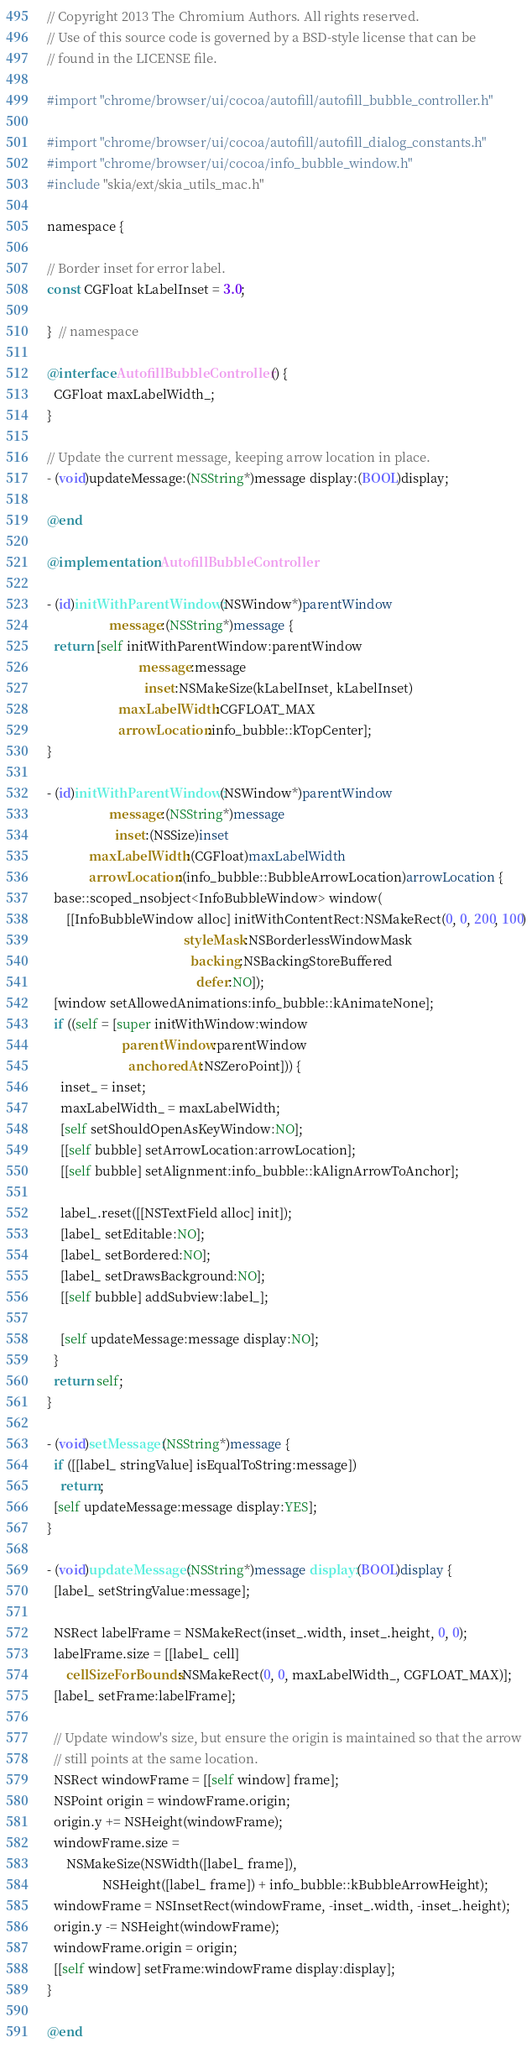<code> <loc_0><loc_0><loc_500><loc_500><_ObjectiveC_>// Copyright 2013 The Chromium Authors. All rights reserved.
// Use of this source code is governed by a BSD-style license that can be
// found in the LICENSE file.

#import "chrome/browser/ui/cocoa/autofill/autofill_bubble_controller.h"

#import "chrome/browser/ui/cocoa/autofill/autofill_dialog_constants.h"
#import "chrome/browser/ui/cocoa/info_bubble_window.h"
#include "skia/ext/skia_utils_mac.h"

namespace {

// Border inset for error label.
const CGFloat kLabelInset = 3.0;

}  // namespace

@interface AutofillBubbleController () {
  CGFloat maxLabelWidth_;
}

// Update the current message, keeping arrow location in place.
- (void)updateMessage:(NSString*)message display:(BOOL)display;

@end

@implementation AutofillBubbleController

- (id)initWithParentWindow:(NSWindow*)parentWindow
                   message:(NSString*)message {
  return [self initWithParentWindow:parentWindow
                            message:message
                              inset:NSMakeSize(kLabelInset, kLabelInset)
                      maxLabelWidth:CGFLOAT_MAX
                      arrowLocation:info_bubble::kTopCenter];
}

- (id)initWithParentWindow:(NSWindow*)parentWindow
                   message:(NSString*)message
                     inset:(NSSize)inset
             maxLabelWidth:(CGFloat)maxLabelWidth
             arrowLocation:(info_bubble::BubbleArrowLocation)arrowLocation {
  base::scoped_nsobject<InfoBubbleWindow> window(
      [[InfoBubbleWindow alloc] initWithContentRect:NSMakeRect(0, 0, 200, 100)
                                          styleMask:NSBorderlessWindowMask
                                            backing:NSBackingStoreBuffered
                                              defer:NO]);
  [window setAllowedAnimations:info_bubble::kAnimateNone];
  if ((self = [super initWithWindow:window
                       parentWindow:parentWindow
                         anchoredAt:NSZeroPoint])) {
    inset_ = inset;
    maxLabelWidth_ = maxLabelWidth;
    [self setShouldOpenAsKeyWindow:NO];
    [[self bubble] setArrowLocation:arrowLocation];
    [[self bubble] setAlignment:info_bubble::kAlignArrowToAnchor];

    label_.reset([[NSTextField alloc] init]);
    [label_ setEditable:NO];
    [label_ setBordered:NO];
    [label_ setDrawsBackground:NO];
    [[self bubble] addSubview:label_];

    [self updateMessage:message display:NO];
  }
  return self;
}

- (void)setMessage:(NSString*)message {
  if ([[label_ stringValue] isEqualToString:message])
    return;
  [self updateMessage:message display:YES];
}

- (void)updateMessage:(NSString*)message display:(BOOL)display {
  [label_ setStringValue:message];

  NSRect labelFrame = NSMakeRect(inset_.width, inset_.height, 0, 0);
  labelFrame.size = [[label_ cell]
      cellSizeForBounds:NSMakeRect(0, 0, maxLabelWidth_, CGFLOAT_MAX)];
  [label_ setFrame:labelFrame];

  // Update window's size, but ensure the origin is maintained so that the arrow
  // still points at the same location.
  NSRect windowFrame = [[self window] frame];
  NSPoint origin = windowFrame.origin;
  origin.y += NSHeight(windowFrame);
  windowFrame.size =
      NSMakeSize(NSWidth([label_ frame]),
                 NSHeight([label_ frame]) + info_bubble::kBubbleArrowHeight);
  windowFrame = NSInsetRect(windowFrame, -inset_.width, -inset_.height);
  origin.y -= NSHeight(windowFrame);
  windowFrame.origin = origin;
  [[self window] setFrame:windowFrame display:display];
}

@end
</code> 